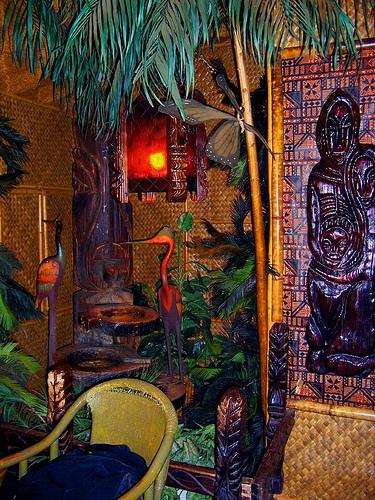Aside from the chair, what other pieces of furniture or decor can be seen? Aside from the chair, there is a carved wooden statue that may serve as a décor piece. There are also tropical plants that enhance the South Pacific theme, and what appears to be a small table or stand to the left of the chair, likely to hold drinks or small items. 